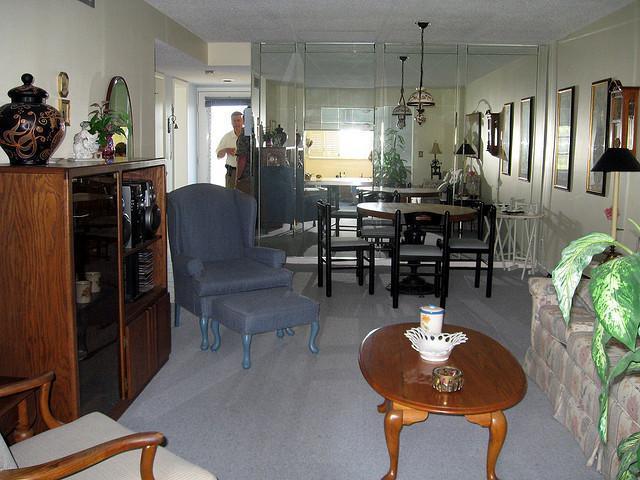What color is the vase in the middle of the coffee table?
Choose the right answer from the provided options to respond to the question.
Options: White, red, green, gold. White. 